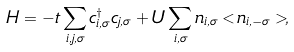<formula> <loc_0><loc_0><loc_500><loc_500>H = - t \sum _ { i , j , \sigma } c ^ { \dagger } _ { i , \sigma } c _ { j , \sigma } + U \sum _ { i , \sigma } n _ { i , \sigma } < n _ { i , - \sigma } > ,</formula> 